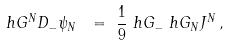<formula> <loc_0><loc_0><loc_500><loc_500>\ h G ^ { N } D _ { - } \psi _ { N } \ & = \ \frac { 1 } { 9 } \ h G _ { - } \ h G _ { N } J ^ { N } \, ,</formula> 